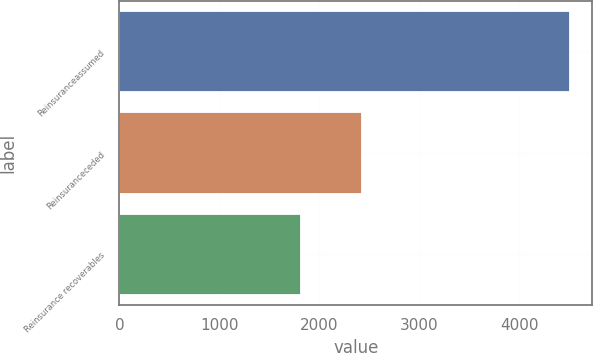Convert chart. <chart><loc_0><loc_0><loc_500><loc_500><bar_chart><fcel>Reinsuranceassumed<fcel>Reinsuranceceded<fcel>Reinsurance recoverables<nl><fcel>4506<fcel>2432<fcel>1813<nl></chart> 